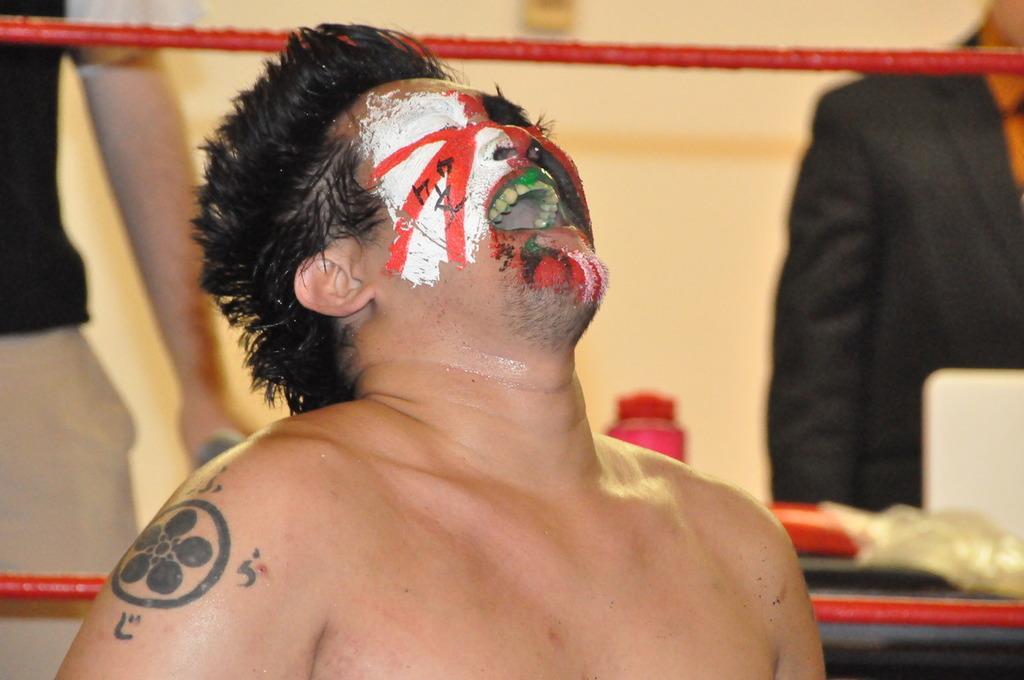In one or two sentences, can you explain what this image depicts? In this picture I can see there is a man and he is having a tattoo on his right hand. He has a painting on his face and in the backdrop, there are two men standing at left and right. 